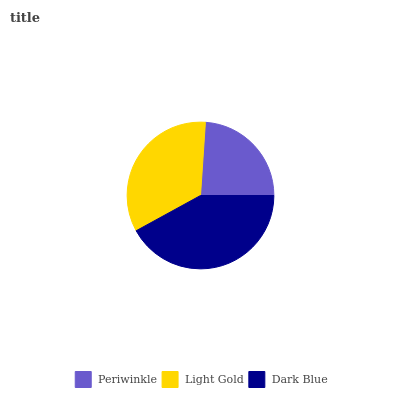Is Periwinkle the minimum?
Answer yes or no. Yes. Is Dark Blue the maximum?
Answer yes or no. Yes. Is Light Gold the minimum?
Answer yes or no. No. Is Light Gold the maximum?
Answer yes or no. No. Is Light Gold greater than Periwinkle?
Answer yes or no. Yes. Is Periwinkle less than Light Gold?
Answer yes or no. Yes. Is Periwinkle greater than Light Gold?
Answer yes or no. No. Is Light Gold less than Periwinkle?
Answer yes or no. No. Is Light Gold the high median?
Answer yes or no. Yes. Is Light Gold the low median?
Answer yes or no. Yes. Is Dark Blue the high median?
Answer yes or no. No. Is Periwinkle the low median?
Answer yes or no. No. 